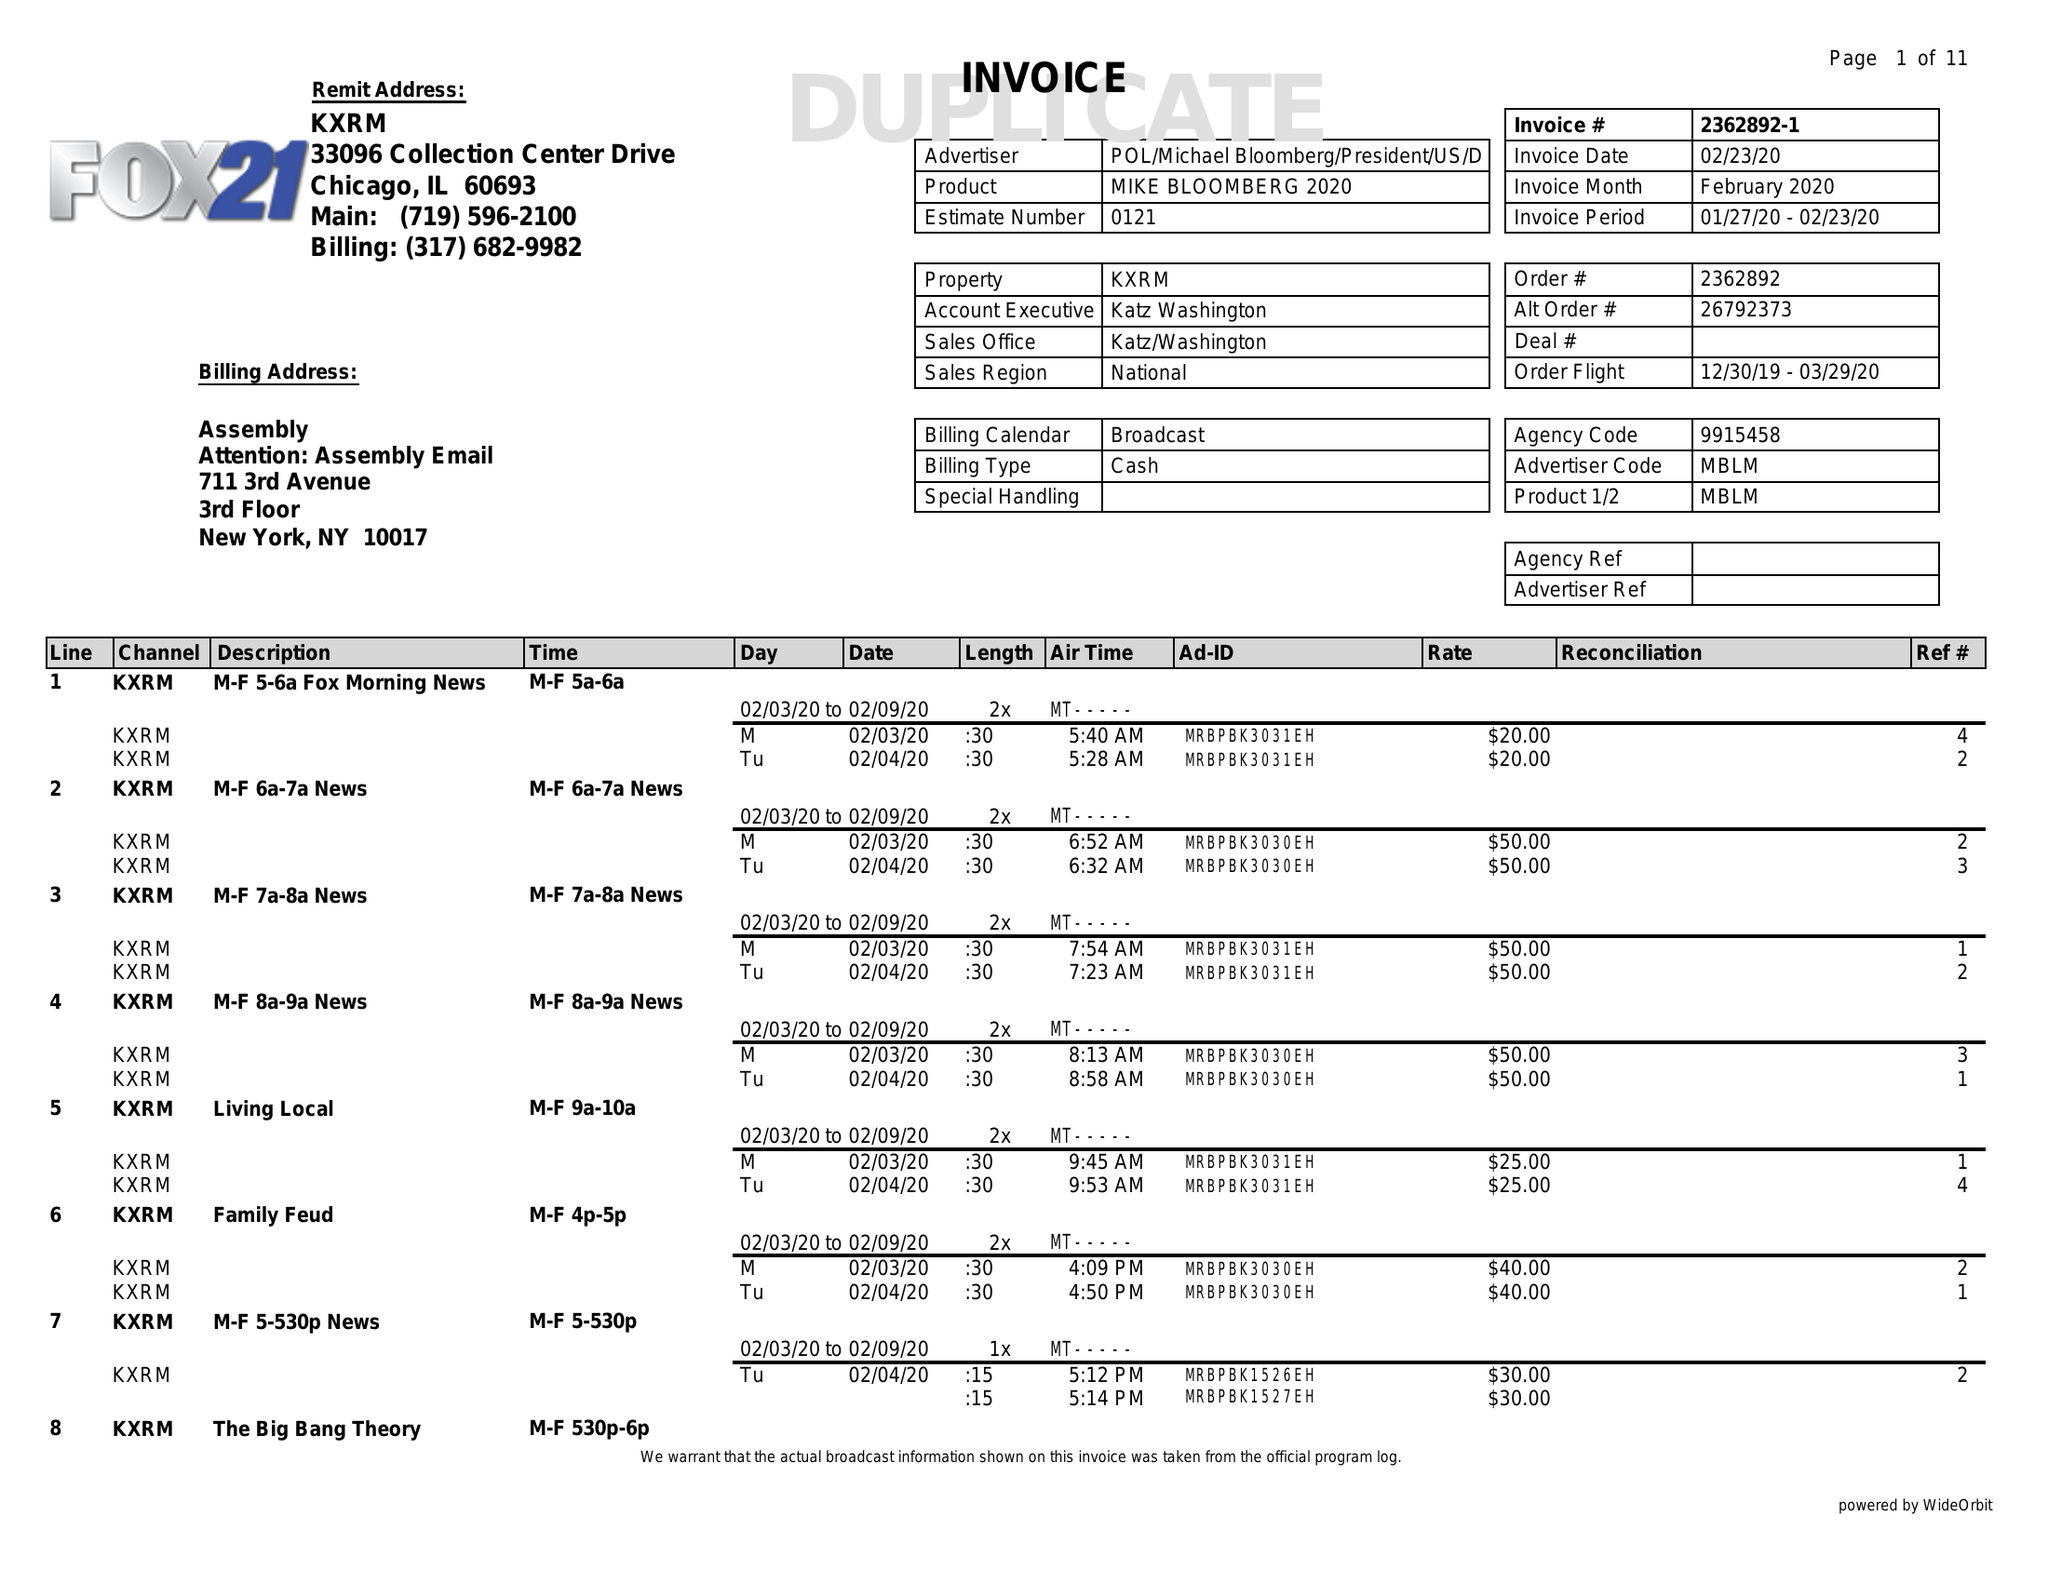What is the value for the gross_amount?
Answer the question using a single word or phrase. 18520.00 